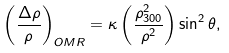<formula> <loc_0><loc_0><loc_500><loc_500>\left ( \frac { \Delta \rho } { \rho } \right ) _ { O M R } = \kappa \left ( \frac { \rho _ { 3 0 0 } ^ { 2 } } { \rho ^ { 2 } } \right ) \sin ^ { 2 } \theta ,</formula> 